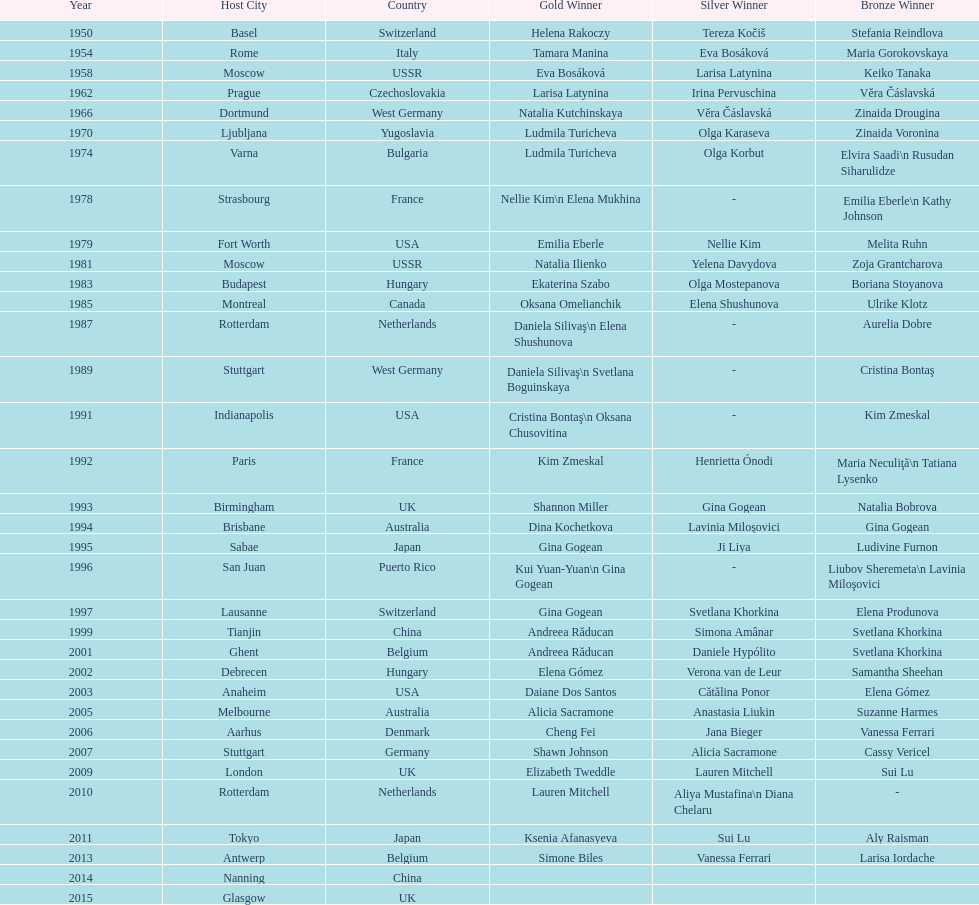How many times was the world artistic gymnastics championships held in the united states? 3. 